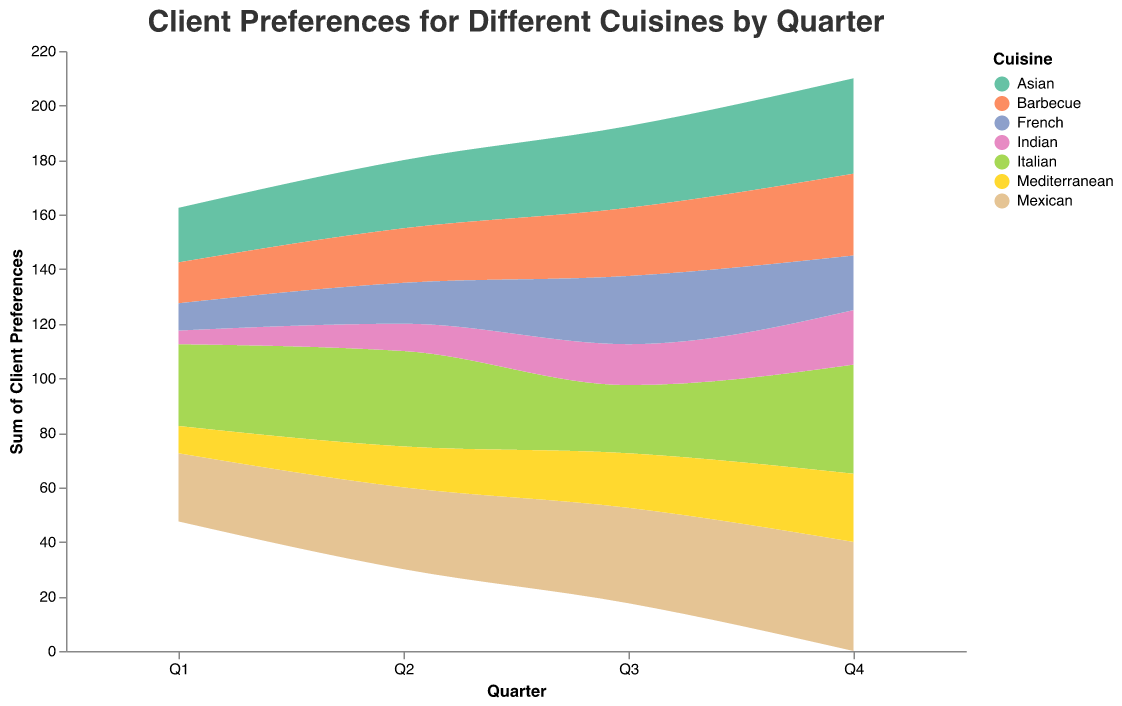What is the title of the figure? The title of the figure is located at the top and it is specified as "Client Preferences for Different Cuisines by Quarter".
Answer: Client Preferences for Different Cuisines by Quarter Which cuisine is preferred the most in Q4 according to the figure? By examining the height of the sections in Q4, we see that Italian and Mexican cuisines have the highest preferences.
Answer: Italian and Mexican Which cuisine has shown a consistent increase in client preferences across all quarters? Looking at the data streams for each cuisine, we notice that Asian cuisine has shown a consistent increase from Q1 to Q4.
Answer: Asian What is the total client preference for Italian cuisine over all quarters? Sum the values of client preferences for Italian cuisine: 30 (Q1) + 35 (Q2) + 25 (Q3) + 40 (Q4) = 130.
Answer: 130 Which quarter has the highest sum of client preferences across all cuisines? Add the client preferences for each cuisine within each quarter. The sums are Q1: 115, Q2: 150, Q3: 175, Q4: 210. Therefore, Q4 has the highest sum.
Answer: Q4 How do Mexican cuisine preferences in Q3 compare to Italian cuisine preferences in the same quarter? Mexican cuisine has 35 client preferences while Italian cuisine has 25 client preferences in Q3. 35 is greater than 25.
Answer: Mexican is preferred more For Barbecue cuisine, what is the average client preference per quarter? The preferences for each quarter are 15, 20, 25, and 30. Adding them gives us 90. Dividing by 4 quarters gives 90/4 = 22.5.
Answer: 22.5 Between Q1 and Q2, which cuisine shows the greatest increase in client preferences? Calculate the increases: Italian (35-30=5), Asian (25-20=5), Barbecue (20-15=5), Mexican (30-25=5), Mediterranean (15-10=5), Indian (10-5=5), French (15-10=5). All cuisines have an equal increase of 5.
Answer: All cuisines (equal increase) How does the pattern of preferences change from Q1 to Q4 for Indian cuisine? Indian cuisine starts at 5 in Q1, rises to 10 in Q2, then to 15 in Q3 and reaches 20 in Q4, indicating a steady rise each quarter.
Answer: Steady Increase What changes can you infer about Mediterranean cuisine's popularity over the quarters? Mediterranean cuisine increases steadily from 10 in Q1 to 25 in Q4. This suggests increasing popularity over time.
Answer: Increasing popularity 